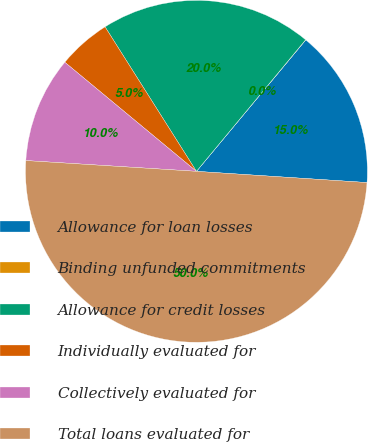Convert chart to OTSL. <chart><loc_0><loc_0><loc_500><loc_500><pie_chart><fcel>Allowance for loan losses<fcel>Binding unfunded commitments<fcel>Allowance for credit losses<fcel>Individually evaluated for<fcel>Collectively evaluated for<fcel>Total loans evaluated for<nl><fcel>15.0%<fcel>0.02%<fcel>20.0%<fcel>5.01%<fcel>10.01%<fcel>49.96%<nl></chart> 